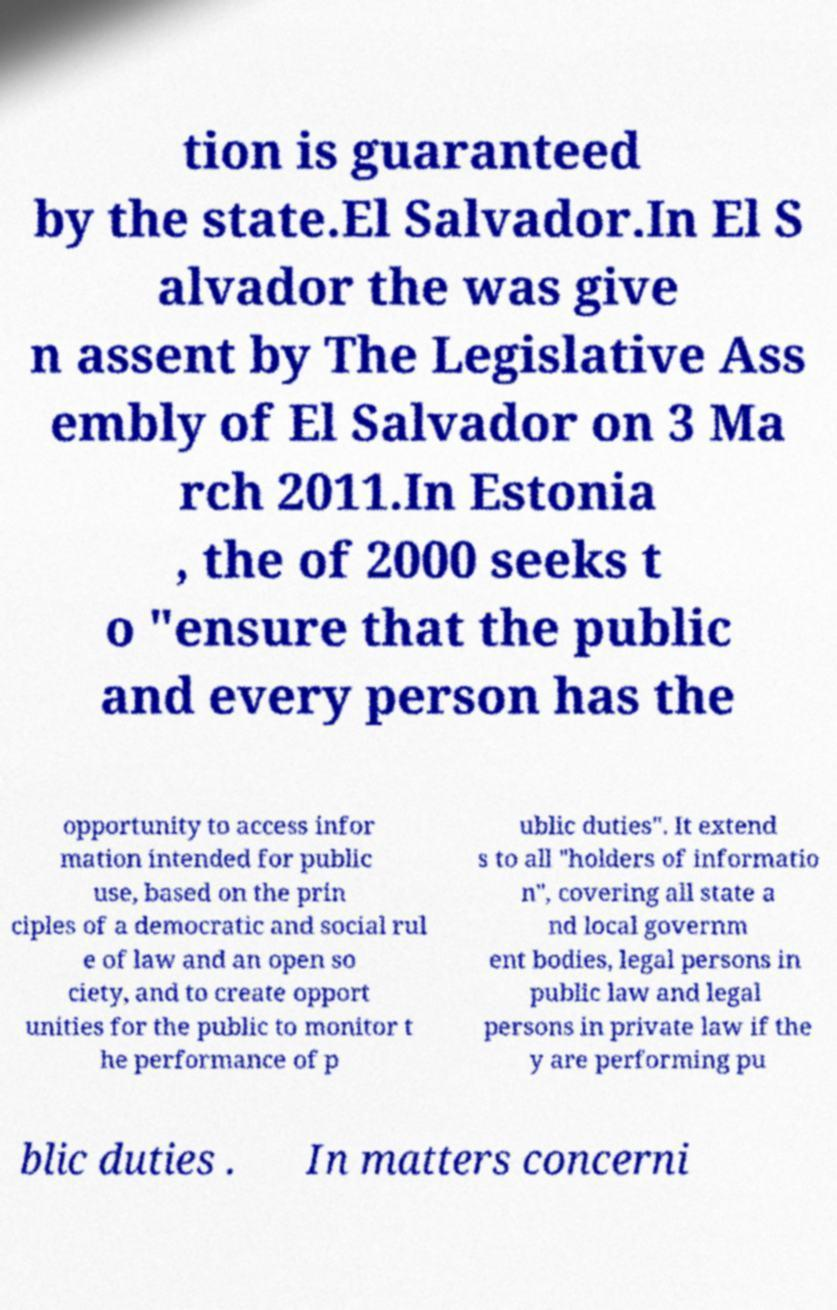Could you extract and type out the text from this image? tion is guaranteed by the state.El Salvador.In El S alvador the was give n assent by The Legislative Ass embly of El Salvador on 3 Ma rch 2011.In Estonia , the of 2000 seeks t o "ensure that the public and every person has the opportunity to access infor mation intended for public use, based on the prin ciples of a democratic and social rul e of law and an open so ciety, and to create opport unities for the public to monitor t he performance of p ublic duties". It extend s to all "holders of informatio n", covering all state a nd local governm ent bodies, legal persons in public law and legal persons in private law if the y are performing pu blic duties . In matters concerni 